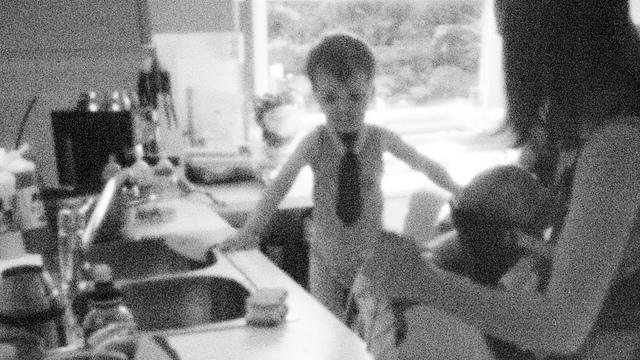What "grown up" item is the small child wearing?
Write a very short answer. Tie. How is the woman holding her youngest child?
Concise answer only. Carrier. Who is wearing the tie?
Answer briefly. Baby. 